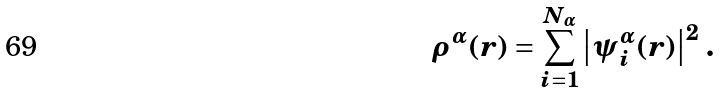Convert formula to latex. <formula><loc_0><loc_0><loc_500><loc_500>\rho ^ { \alpha } ( { r } ) = \sum _ { i = 1 } ^ { N _ { \alpha } } \left | \psi _ { i } ^ { \alpha } ( { r } ) \right | ^ { 2 } \, .</formula> 